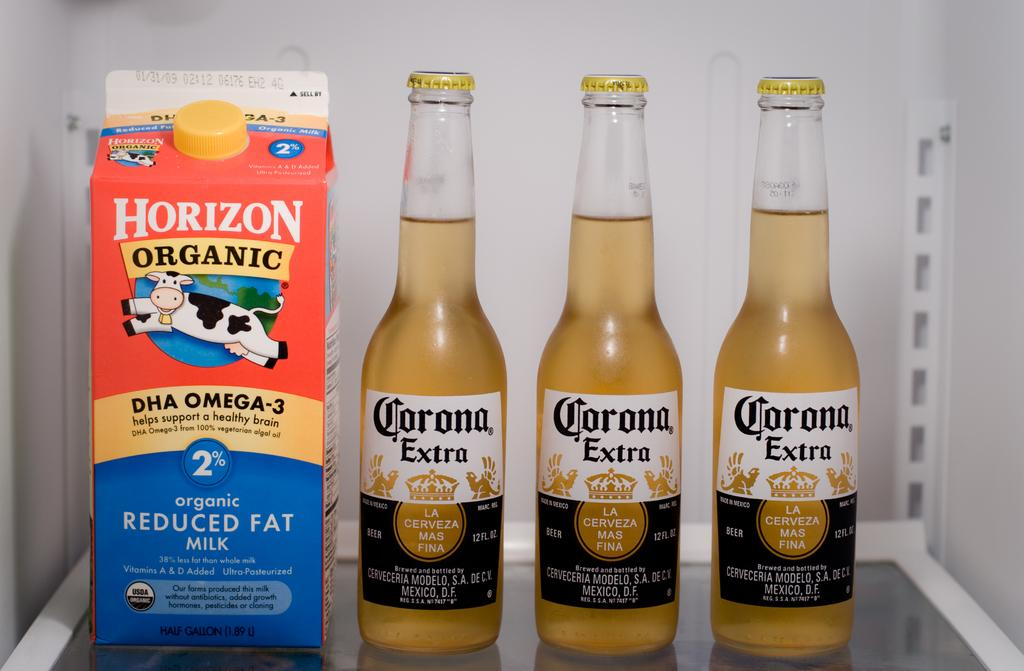<image>
Provide a brief description of the given image. Three bottles of Corona Extra next to a carton of Horizon Organic Milk. 